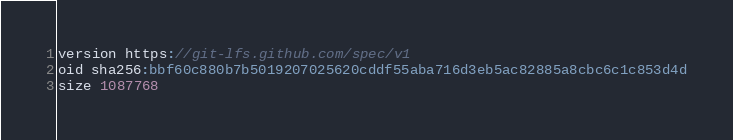<code> <loc_0><loc_0><loc_500><loc_500><_TypeScript_>version https://git-lfs.github.com/spec/v1
oid sha256:bbf60c880b7b5019207025620cddf55aba716d3eb5ac82885a8cbc6c1c853d4d
size 1087768
</code> 